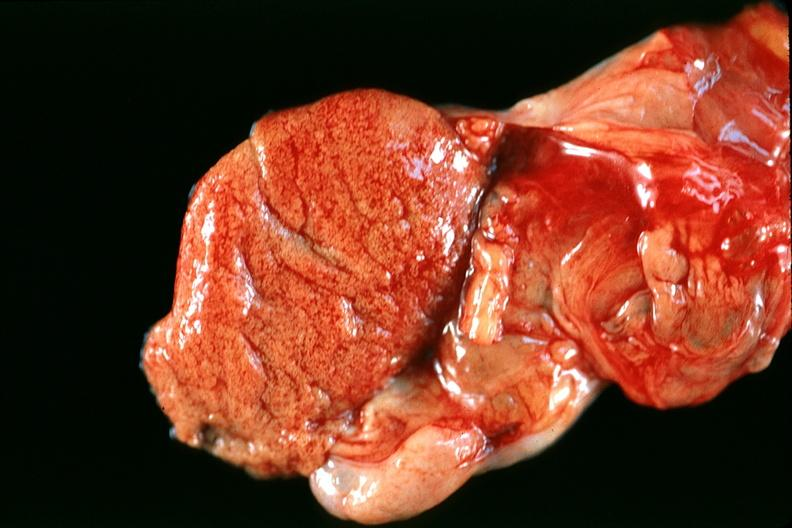what does this image show?
Answer the question using a single word or phrase. Normal testes 